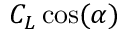<formula> <loc_0><loc_0><loc_500><loc_500>C _ { L } \cos ( \alpha )</formula> 